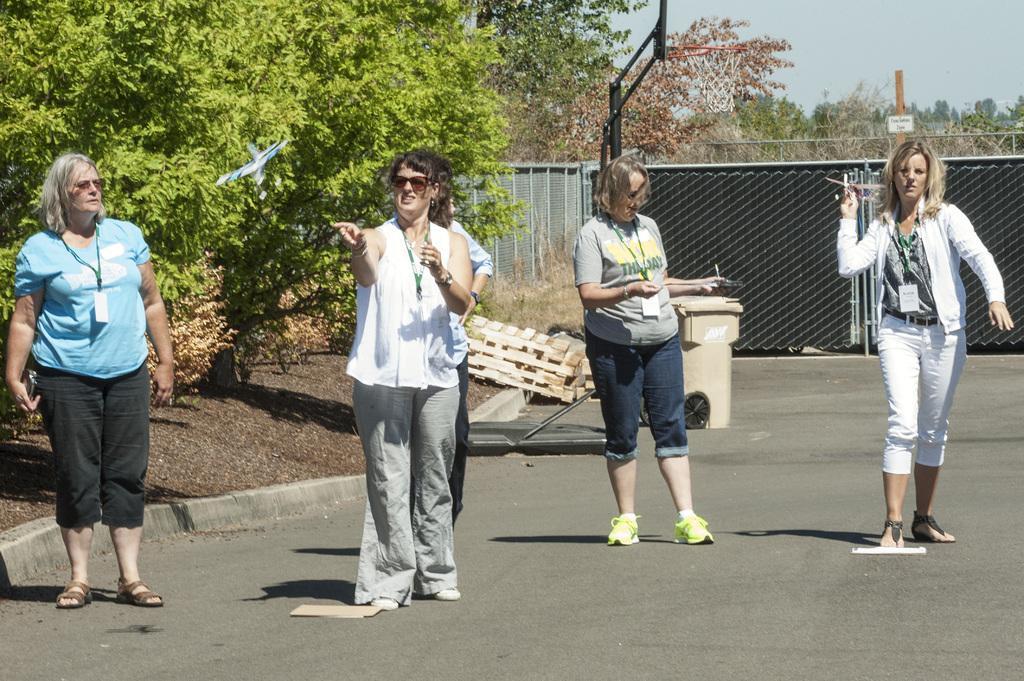Could you give a brief overview of what you see in this image? In the center of the image there are group of women standing on the road. On the left side of the image we can see a tree, plants and woman standing on the road. On the right side of the image we can see woman standing on the road. In the background there is a fencing, gate, trees and sky. 